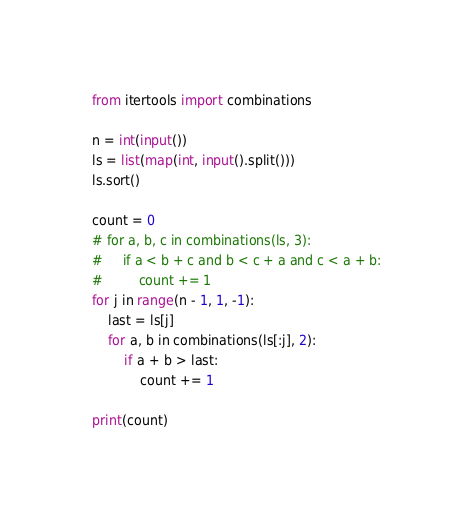<code> <loc_0><loc_0><loc_500><loc_500><_Python_>from itertools import combinations

n = int(input())
ls = list(map(int, input().split()))
ls.sort()

count = 0
# for a, b, c in combinations(ls, 3):
#     if a < b + c and b < c + a and c < a + b:
#         count += 1
for j in range(n - 1, 1, -1):
    last = ls[j]
    for a, b in combinations(ls[:j], 2):
        if a + b > last:
            count += 1

print(count)</code> 